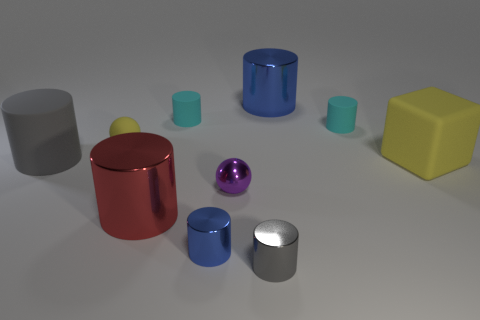Subtract all blue cylinders. How many were subtracted if there are1blue cylinders left? 1 Subtract all small blue cylinders. How many cylinders are left? 6 Subtract all purple balls. How many balls are left? 1 Add 5 tiny gray shiny things. How many tiny gray shiny things exist? 6 Subtract 1 gray cylinders. How many objects are left? 9 Subtract all spheres. How many objects are left? 8 Subtract 1 cubes. How many cubes are left? 0 Subtract all red cylinders. Subtract all red cubes. How many cylinders are left? 6 Subtract all blue cylinders. How many gray cubes are left? 0 Subtract all tiny red metal objects. Subtract all cyan matte cylinders. How many objects are left? 8 